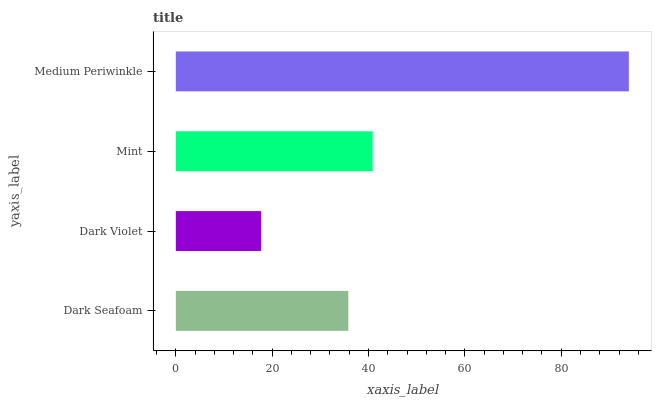Is Dark Violet the minimum?
Answer yes or no. Yes. Is Medium Periwinkle the maximum?
Answer yes or no. Yes. Is Mint the minimum?
Answer yes or no. No. Is Mint the maximum?
Answer yes or no. No. Is Mint greater than Dark Violet?
Answer yes or no. Yes. Is Dark Violet less than Mint?
Answer yes or no. Yes. Is Dark Violet greater than Mint?
Answer yes or no. No. Is Mint less than Dark Violet?
Answer yes or no. No. Is Mint the high median?
Answer yes or no. Yes. Is Dark Seafoam the low median?
Answer yes or no. Yes. Is Medium Periwinkle the high median?
Answer yes or no. No. Is Mint the low median?
Answer yes or no. No. 